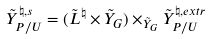<formula> <loc_0><loc_0><loc_500><loc_500>\tilde { Y } _ { P / U } ^ { \natural , s } = ( \tilde { L } ^ { \natural } \times \tilde { Y } _ { G } ) \times _ { \tilde { Y } _ { G } } \tilde { Y } ^ { \natural , e x t r } _ { P / U }</formula> 